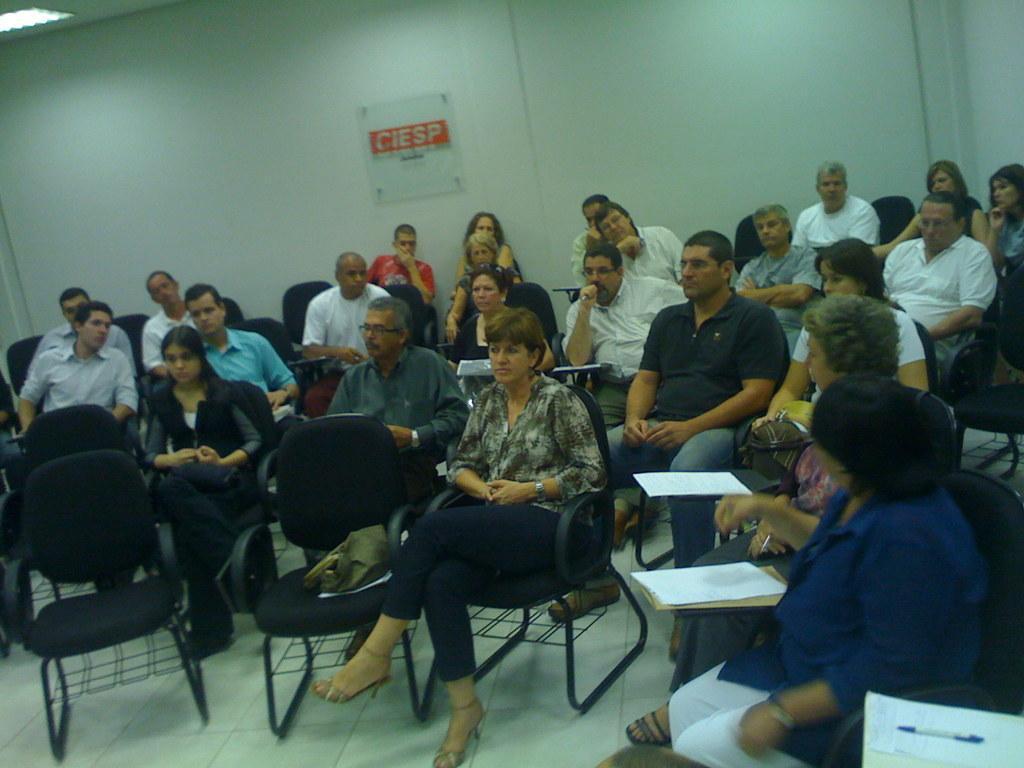Describe this image in one or two sentences. there are group of people sitting in a room on the chairs. the left most woman is wearing a blue shirt and a white pant. behind them there is a wall and a note written as CIESP. 